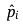Convert formula to latex. <formula><loc_0><loc_0><loc_500><loc_500>\hat { p } _ { i }</formula> 